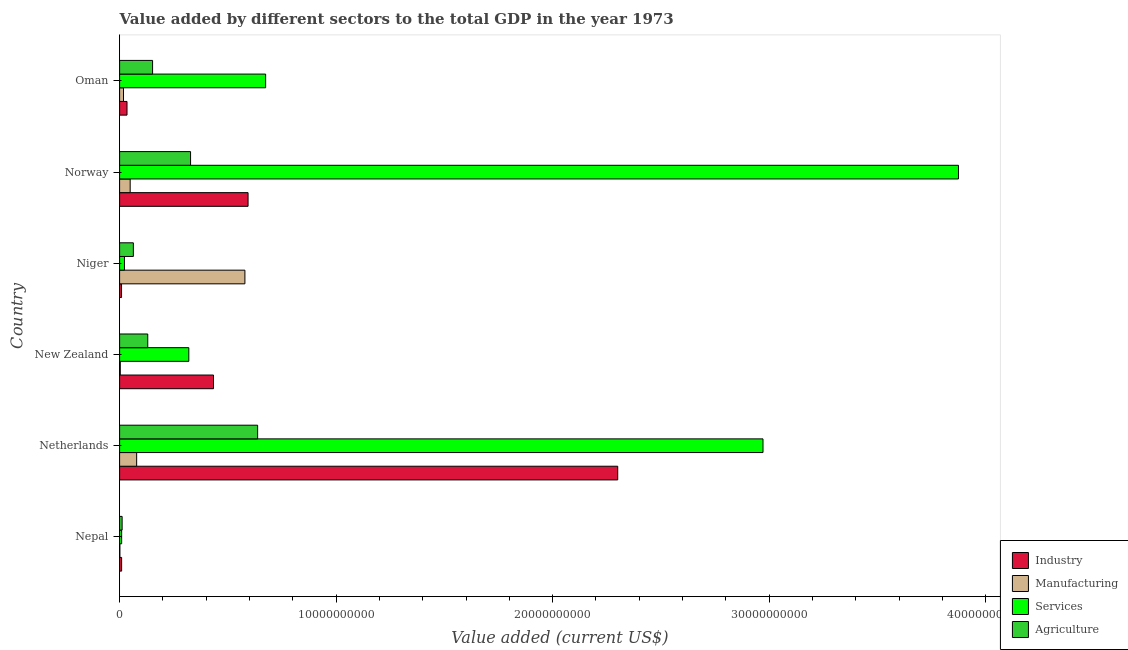How many different coloured bars are there?
Provide a succinct answer. 4. How many groups of bars are there?
Provide a succinct answer. 6. How many bars are there on the 6th tick from the top?
Offer a very short reply. 4. What is the label of the 4th group of bars from the top?
Offer a very short reply. New Zealand. In how many cases, is the number of bars for a given country not equal to the number of legend labels?
Provide a short and direct response. 0. What is the value added by industrial sector in Oman?
Your response must be concise. 3.42e+08. Across all countries, what is the maximum value added by agricultural sector?
Keep it short and to the point. 6.37e+09. Across all countries, what is the minimum value added by industrial sector?
Ensure brevity in your answer.  8.87e+07. In which country was the value added by agricultural sector minimum?
Keep it short and to the point. Nepal. What is the total value added by industrial sector in the graph?
Offer a very short reply. 3.38e+1. What is the difference between the value added by agricultural sector in Niger and that in Norway?
Your response must be concise. -2.64e+09. What is the difference between the value added by manufacturing sector in Norway and the value added by agricultural sector in Oman?
Your answer should be compact. -1.04e+09. What is the average value added by agricultural sector per country?
Provide a short and direct response. 2.20e+09. What is the difference between the value added by manufacturing sector and value added by agricultural sector in Niger?
Provide a succinct answer. 5.15e+09. What is the ratio of the value added by agricultural sector in Norway to that in Oman?
Give a very brief answer. 2.15. Is the value added by services sector in New Zealand less than that in Niger?
Your answer should be compact. No. What is the difference between the highest and the second highest value added by agricultural sector?
Your answer should be compact. 3.10e+09. What is the difference between the highest and the lowest value added by services sector?
Make the answer very short. 3.86e+1. In how many countries, is the value added by manufacturing sector greater than the average value added by manufacturing sector taken over all countries?
Ensure brevity in your answer.  1. What does the 1st bar from the top in Norway represents?
Provide a succinct answer. Agriculture. What does the 3rd bar from the bottom in Norway represents?
Offer a terse response. Services. Is it the case that in every country, the sum of the value added by industrial sector and value added by manufacturing sector is greater than the value added by services sector?
Your response must be concise. No. How many bars are there?
Your answer should be compact. 24. Are all the bars in the graph horizontal?
Offer a very short reply. Yes. Does the graph contain grids?
Provide a short and direct response. No. How are the legend labels stacked?
Provide a short and direct response. Vertical. What is the title of the graph?
Your answer should be compact. Value added by different sectors to the total GDP in the year 1973. Does "Minerals" appear as one of the legend labels in the graph?
Make the answer very short. No. What is the label or title of the X-axis?
Give a very brief answer. Value added (current US$). What is the Value added (current US$) in Industry in Nepal?
Offer a terse response. 9.32e+07. What is the Value added (current US$) of Manufacturing in Nepal?
Provide a short and direct response. 1.19e+07. What is the Value added (current US$) in Services in Nepal?
Provide a short and direct response. 9.44e+07. What is the Value added (current US$) of Agriculture in Nepal?
Provide a short and direct response. 1.17e+08. What is the Value added (current US$) of Industry in Netherlands?
Give a very brief answer. 2.30e+1. What is the Value added (current US$) in Manufacturing in Netherlands?
Give a very brief answer. 7.87e+08. What is the Value added (current US$) in Services in Netherlands?
Provide a short and direct response. 2.97e+1. What is the Value added (current US$) in Agriculture in Netherlands?
Your answer should be compact. 6.37e+09. What is the Value added (current US$) of Industry in New Zealand?
Give a very brief answer. 4.34e+09. What is the Value added (current US$) in Manufacturing in New Zealand?
Your answer should be very brief. 3.16e+07. What is the Value added (current US$) of Services in New Zealand?
Provide a short and direct response. 3.20e+09. What is the Value added (current US$) of Agriculture in New Zealand?
Ensure brevity in your answer.  1.30e+09. What is the Value added (current US$) in Industry in Niger?
Keep it short and to the point. 8.87e+07. What is the Value added (current US$) of Manufacturing in Niger?
Provide a succinct answer. 5.79e+09. What is the Value added (current US$) of Services in Niger?
Your answer should be very brief. 2.24e+08. What is the Value added (current US$) of Agriculture in Niger?
Keep it short and to the point. 6.35e+08. What is the Value added (current US$) in Industry in Norway?
Keep it short and to the point. 5.93e+09. What is the Value added (current US$) of Manufacturing in Norway?
Offer a terse response. 4.88e+08. What is the Value added (current US$) of Services in Norway?
Offer a terse response. 3.87e+1. What is the Value added (current US$) in Agriculture in Norway?
Give a very brief answer. 3.28e+09. What is the Value added (current US$) in Industry in Oman?
Your answer should be very brief. 3.42e+08. What is the Value added (current US$) in Manufacturing in Oman?
Provide a short and direct response. 1.80e+08. What is the Value added (current US$) in Services in Oman?
Offer a terse response. 6.74e+09. What is the Value added (current US$) of Agriculture in Oman?
Offer a terse response. 1.52e+09. Across all countries, what is the maximum Value added (current US$) in Industry?
Make the answer very short. 2.30e+1. Across all countries, what is the maximum Value added (current US$) in Manufacturing?
Give a very brief answer. 5.79e+09. Across all countries, what is the maximum Value added (current US$) of Services?
Your answer should be very brief. 3.87e+1. Across all countries, what is the maximum Value added (current US$) in Agriculture?
Your answer should be very brief. 6.37e+09. Across all countries, what is the minimum Value added (current US$) in Industry?
Ensure brevity in your answer.  8.87e+07. Across all countries, what is the minimum Value added (current US$) of Manufacturing?
Ensure brevity in your answer.  1.19e+07. Across all countries, what is the minimum Value added (current US$) in Services?
Your answer should be compact. 9.44e+07. Across all countries, what is the minimum Value added (current US$) of Agriculture?
Provide a short and direct response. 1.17e+08. What is the total Value added (current US$) of Industry in the graph?
Ensure brevity in your answer.  3.38e+1. What is the total Value added (current US$) in Manufacturing in the graph?
Ensure brevity in your answer.  7.29e+09. What is the total Value added (current US$) of Services in the graph?
Your answer should be very brief. 7.87e+1. What is the total Value added (current US$) in Agriculture in the graph?
Provide a succinct answer. 1.32e+1. What is the difference between the Value added (current US$) of Industry in Nepal and that in Netherlands?
Offer a very short reply. -2.29e+1. What is the difference between the Value added (current US$) in Manufacturing in Nepal and that in Netherlands?
Your response must be concise. -7.75e+08. What is the difference between the Value added (current US$) in Services in Nepal and that in Netherlands?
Make the answer very short. -2.96e+1. What is the difference between the Value added (current US$) in Agriculture in Nepal and that in Netherlands?
Provide a short and direct response. -6.26e+09. What is the difference between the Value added (current US$) of Industry in Nepal and that in New Zealand?
Give a very brief answer. -4.24e+09. What is the difference between the Value added (current US$) of Manufacturing in Nepal and that in New Zealand?
Your answer should be very brief. -1.97e+07. What is the difference between the Value added (current US$) in Services in Nepal and that in New Zealand?
Provide a short and direct response. -3.10e+09. What is the difference between the Value added (current US$) in Agriculture in Nepal and that in New Zealand?
Your answer should be compact. -1.18e+09. What is the difference between the Value added (current US$) of Industry in Nepal and that in Niger?
Provide a short and direct response. 4.47e+06. What is the difference between the Value added (current US$) of Manufacturing in Nepal and that in Niger?
Give a very brief answer. -5.78e+09. What is the difference between the Value added (current US$) of Services in Nepal and that in Niger?
Ensure brevity in your answer.  -1.29e+08. What is the difference between the Value added (current US$) of Agriculture in Nepal and that in Niger?
Provide a short and direct response. -5.18e+08. What is the difference between the Value added (current US$) of Industry in Nepal and that in Norway?
Offer a terse response. -5.84e+09. What is the difference between the Value added (current US$) of Manufacturing in Nepal and that in Norway?
Make the answer very short. -4.76e+08. What is the difference between the Value added (current US$) in Services in Nepal and that in Norway?
Offer a very short reply. -3.86e+1. What is the difference between the Value added (current US$) in Agriculture in Nepal and that in Norway?
Your answer should be very brief. -3.16e+09. What is the difference between the Value added (current US$) of Industry in Nepal and that in Oman?
Make the answer very short. -2.49e+08. What is the difference between the Value added (current US$) of Manufacturing in Nepal and that in Oman?
Give a very brief answer. -1.68e+08. What is the difference between the Value added (current US$) in Services in Nepal and that in Oman?
Offer a terse response. -6.65e+09. What is the difference between the Value added (current US$) in Agriculture in Nepal and that in Oman?
Provide a succinct answer. -1.41e+09. What is the difference between the Value added (current US$) in Industry in Netherlands and that in New Zealand?
Your answer should be compact. 1.87e+1. What is the difference between the Value added (current US$) in Manufacturing in Netherlands and that in New Zealand?
Offer a very short reply. 7.56e+08. What is the difference between the Value added (current US$) of Services in Netherlands and that in New Zealand?
Ensure brevity in your answer.  2.65e+1. What is the difference between the Value added (current US$) in Agriculture in Netherlands and that in New Zealand?
Your response must be concise. 5.07e+09. What is the difference between the Value added (current US$) in Industry in Netherlands and that in Niger?
Ensure brevity in your answer.  2.29e+1. What is the difference between the Value added (current US$) in Manufacturing in Netherlands and that in Niger?
Make the answer very short. -5.00e+09. What is the difference between the Value added (current US$) in Services in Netherlands and that in Niger?
Provide a succinct answer. 2.95e+1. What is the difference between the Value added (current US$) in Agriculture in Netherlands and that in Niger?
Provide a short and direct response. 5.74e+09. What is the difference between the Value added (current US$) of Industry in Netherlands and that in Norway?
Your response must be concise. 1.71e+1. What is the difference between the Value added (current US$) of Manufacturing in Netherlands and that in Norway?
Provide a succinct answer. 2.99e+08. What is the difference between the Value added (current US$) of Services in Netherlands and that in Norway?
Ensure brevity in your answer.  -9.03e+09. What is the difference between the Value added (current US$) of Agriculture in Netherlands and that in Norway?
Your answer should be compact. 3.10e+09. What is the difference between the Value added (current US$) in Industry in Netherlands and that in Oman?
Give a very brief answer. 2.27e+1. What is the difference between the Value added (current US$) in Manufacturing in Netherlands and that in Oman?
Your answer should be very brief. 6.07e+08. What is the difference between the Value added (current US$) of Services in Netherlands and that in Oman?
Your answer should be compact. 2.30e+1. What is the difference between the Value added (current US$) in Agriculture in Netherlands and that in Oman?
Ensure brevity in your answer.  4.85e+09. What is the difference between the Value added (current US$) of Industry in New Zealand and that in Niger?
Keep it short and to the point. 4.25e+09. What is the difference between the Value added (current US$) in Manufacturing in New Zealand and that in Niger?
Provide a succinct answer. -5.76e+09. What is the difference between the Value added (current US$) of Services in New Zealand and that in Niger?
Your answer should be very brief. 2.97e+09. What is the difference between the Value added (current US$) of Agriculture in New Zealand and that in Niger?
Keep it short and to the point. 6.65e+08. What is the difference between the Value added (current US$) of Industry in New Zealand and that in Norway?
Your answer should be very brief. -1.60e+09. What is the difference between the Value added (current US$) in Manufacturing in New Zealand and that in Norway?
Your answer should be very brief. -4.56e+08. What is the difference between the Value added (current US$) of Services in New Zealand and that in Norway?
Give a very brief answer. -3.55e+1. What is the difference between the Value added (current US$) in Agriculture in New Zealand and that in Norway?
Provide a short and direct response. -1.98e+09. What is the difference between the Value added (current US$) in Industry in New Zealand and that in Oman?
Your answer should be compact. 3.99e+09. What is the difference between the Value added (current US$) of Manufacturing in New Zealand and that in Oman?
Ensure brevity in your answer.  -1.48e+08. What is the difference between the Value added (current US$) of Services in New Zealand and that in Oman?
Your answer should be compact. -3.55e+09. What is the difference between the Value added (current US$) in Agriculture in New Zealand and that in Oman?
Provide a succinct answer. -2.23e+08. What is the difference between the Value added (current US$) in Industry in Niger and that in Norway?
Offer a very short reply. -5.84e+09. What is the difference between the Value added (current US$) of Manufacturing in Niger and that in Norway?
Provide a succinct answer. 5.30e+09. What is the difference between the Value added (current US$) of Services in Niger and that in Norway?
Offer a terse response. -3.85e+1. What is the difference between the Value added (current US$) in Agriculture in Niger and that in Norway?
Offer a very short reply. -2.64e+09. What is the difference between the Value added (current US$) of Industry in Niger and that in Oman?
Keep it short and to the point. -2.53e+08. What is the difference between the Value added (current US$) of Manufacturing in Niger and that in Oman?
Provide a short and direct response. 5.61e+09. What is the difference between the Value added (current US$) in Services in Niger and that in Oman?
Give a very brief answer. -6.52e+09. What is the difference between the Value added (current US$) in Agriculture in Niger and that in Oman?
Your response must be concise. -8.88e+08. What is the difference between the Value added (current US$) of Industry in Norway and that in Oman?
Ensure brevity in your answer.  5.59e+09. What is the difference between the Value added (current US$) of Manufacturing in Norway and that in Oman?
Ensure brevity in your answer.  3.08e+08. What is the difference between the Value added (current US$) of Services in Norway and that in Oman?
Provide a short and direct response. 3.20e+1. What is the difference between the Value added (current US$) of Agriculture in Norway and that in Oman?
Your answer should be compact. 1.75e+09. What is the difference between the Value added (current US$) in Industry in Nepal and the Value added (current US$) in Manufacturing in Netherlands?
Your answer should be very brief. -6.94e+08. What is the difference between the Value added (current US$) of Industry in Nepal and the Value added (current US$) of Services in Netherlands?
Provide a succinct answer. -2.96e+1. What is the difference between the Value added (current US$) in Industry in Nepal and the Value added (current US$) in Agriculture in Netherlands?
Provide a succinct answer. -6.28e+09. What is the difference between the Value added (current US$) of Manufacturing in Nepal and the Value added (current US$) of Services in Netherlands?
Your response must be concise. -2.97e+1. What is the difference between the Value added (current US$) in Manufacturing in Nepal and the Value added (current US$) in Agriculture in Netherlands?
Ensure brevity in your answer.  -6.36e+09. What is the difference between the Value added (current US$) in Services in Nepal and the Value added (current US$) in Agriculture in Netherlands?
Offer a very short reply. -6.28e+09. What is the difference between the Value added (current US$) of Industry in Nepal and the Value added (current US$) of Manufacturing in New Zealand?
Give a very brief answer. 6.16e+07. What is the difference between the Value added (current US$) in Industry in Nepal and the Value added (current US$) in Services in New Zealand?
Provide a short and direct response. -3.10e+09. What is the difference between the Value added (current US$) of Industry in Nepal and the Value added (current US$) of Agriculture in New Zealand?
Your answer should be compact. -1.21e+09. What is the difference between the Value added (current US$) in Manufacturing in Nepal and the Value added (current US$) in Services in New Zealand?
Give a very brief answer. -3.18e+09. What is the difference between the Value added (current US$) in Manufacturing in Nepal and the Value added (current US$) in Agriculture in New Zealand?
Make the answer very short. -1.29e+09. What is the difference between the Value added (current US$) of Services in Nepal and the Value added (current US$) of Agriculture in New Zealand?
Keep it short and to the point. -1.21e+09. What is the difference between the Value added (current US$) of Industry in Nepal and the Value added (current US$) of Manufacturing in Niger?
Ensure brevity in your answer.  -5.69e+09. What is the difference between the Value added (current US$) in Industry in Nepal and the Value added (current US$) in Services in Niger?
Offer a terse response. -1.31e+08. What is the difference between the Value added (current US$) of Industry in Nepal and the Value added (current US$) of Agriculture in Niger?
Ensure brevity in your answer.  -5.42e+08. What is the difference between the Value added (current US$) in Manufacturing in Nepal and the Value added (current US$) in Services in Niger?
Your response must be concise. -2.12e+08. What is the difference between the Value added (current US$) of Manufacturing in Nepal and the Value added (current US$) of Agriculture in Niger?
Make the answer very short. -6.23e+08. What is the difference between the Value added (current US$) of Services in Nepal and the Value added (current US$) of Agriculture in Niger?
Give a very brief answer. -5.41e+08. What is the difference between the Value added (current US$) in Industry in Nepal and the Value added (current US$) in Manufacturing in Norway?
Your response must be concise. -3.95e+08. What is the difference between the Value added (current US$) in Industry in Nepal and the Value added (current US$) in Services in Norway?
Ensure brevity in your answer.  -3.86e+1. What is the difference between the Value added (current US$) of Industry in Nepal and the Value added (current US$) of Agriculture in Norway?
Your response must be concise. -3.18e+09. What is the difference between the Value added (current US$) in Manufacturing in Nepal and the Value added (current US$) in Services in Norway?
Give a very brief answer. -3.87e+1. What is the difference between the Value added (current US$) of Manufacturing in Nepal and the Value added (current US$) of Agriculture in Norway?
Your answer should be very brief. -3.27e+09. What is the difference between the Value added (current US$) of Services in Nepal and the Value added (current US$) of Agriculture in Norway?
Keep it short and to the point. -3.18e+09. What is the difference between the Value added (current US$) of Industry in Nepal and the Value added (current US$) of Manufacturing in Oman?
Make the answer very short. -8.66e+07. What is the difference between the Value added (current US$) in Industry in Nepal and the Value added (current US$) in Services in Oman?
Your answer should be very brief. -6.65e+09. What is the difference between the Value added (current US$) of Industry in Nepal and the Value added (current US$) of Agriculture in Oman?
Your answer should be very brief. -1.43e+09. What is the difference between the Value added (current US$) of Manufacturing in Nepal and the Value added (current US$) of Services in Oman?
Ensure brevity in your answer.  -6.73e+09. What is the difference between the Value added (current US$) of Manufacturing in Nepal and the Value added (current US$) of Agriculture in Oman?
Keep it short and to the point. -1.51e+09. What is the difference between the Value added (current US$) in Services in Nepal and the Value added (current US$) in Agriculture in Oman?
Provide a short and direct response. -1.43e+09. What is the difference between the Value added (current US$) in Industry in Netherlands and the Value added (current US$) in Manufacturing in New Zealand?
Your answer should be very brief. 2.30e+1. What is the difference between the Value added (current US$) in Industry in Netherlands and the Value added (current US$) in Services in New Zealand?
Your response must be concise. 1.98e+1. What is the difference between the Value added (current US$) in Industry in Netherlands and the Value added (current US$) in Agriculture in New Zealand?
Ensure brevity in your answer.  2.17e+1. What is the difference between the Value added (current US$) in Manufacturing in Netherlands and the Value added (current US$) in Services in New Zealand?
Keep it short and to the point. -2.41e+09. What is the difference between the Value added (current US$) of Manufacturing in Netherlands and the Value added (current US$) of Agriculture in New Zealand?
Your answer should be very brief. -5.13e+08. What is the difference between the Value added (current US$) of Services in Netherlands and the Value added (current US$) of Agriculture in New Zealand?
Provide a succinct answer. 2.84e+1. What is the difference between the Value added (current US$) in Industry in Netherlands and the Value added (current US$) in Manufacturing in Niger?
Your answer should be very brief. 1.72e+1. What is the difference between the Value added (current US$) in Industry in Netherlands and the Value added (current US$) in Services in Niger?
Give a very brief answer. 2.28e+1. What is the difference between the Value added (current US$) of Industry in Netherlands and the Value added (current US$) of Agriculture in Niger?
Ensure brevity in your answer.  2.24e+1. What is the difference between the Value added (current US$) of Manufacturing in Netherlands and the Value added (current US$) of Services in Niger?
Your answer should be very brief. 5.63e+08. What is the difference between the Value added (current US$) of Manufacturing in Netherlands and the Value added (current US$) of Agriculture in Niger?
Give a very brief answer. 1.52e+08. What is the difference between the Value added (current US$) in Services in Netherlands and the Value added (current US$) in Agriculture in Niger?
Your response must be concise. 2.91e+1. What is the difference between the Value added (current US$) of Industry in Netherlands and the Value added (current US$) of Manufacturing in Norway?
Make the answer very short. 2.25e+1. What is the difference between the Value added (current US$) of Industry in Netherlands and the Value added (current US$) of Services in Norway?
Offer a very short reply. -1.57e+1. What is the difference between the Value added (current US$) in Industry in Netherlands and the Value added (current US$) in Agriculture in Norway?
Ensure brevity in your answer.  1.97e+1. What is the difference between the Value added (current US$) of Manufacturing in Netherlands and the Value added (current US$) of Services in Norway?
Give a very brief answer. -3.80e+1. What is the difference between the Value added (current US$) in Manufacturing in Netherlands and the Value added (current US$) in Agriculture in Norway?
Provide a short and direct response. -2.49e+09. What is the difference between the Value added (current US$) of Services in Netherlands and the Value added (current US$) of Agriculture in Norway?
Keep it short and to the point. 2.64e+1. What is the difference between the Value added (current US$) of Industry in Netherlands and the Value added (current US$) of Manufacturing in Oman?
Offer a terse response. 2.28e+1. What is the difference between the Value added (current US$) in Industry in Netherlands and the Value added (current US$) in Services in Oman?
Ensure brevity in your answer.  1.63e+1. What is the difference between the Value added (current US$) in Industry in Netherlands and the Value added (current US$) in Agriculture in Oman?
Offer a very short reply. 2.15e+1. What is the difference between the Value added (current US$) of Manufacturing in Netherlands and the Value added (current US$) of Services in Oman?
Provide a succinct answer. -5.96e+09. What is the difference between the Value added (current US$) in Manufacturing in Netherlands and the Value added (current US$) in Agriculture in Oman?
Make the answer very short. -7.36e+08. What is the difference between the Value added (current US$) in Services in Netherlands and the Value added (current US$) in Agriculture in Oman?
Provide a short and direct response. 2.82e+1. What is the difference between the Value added (current US$) of Industry in New Zealand and the Value added (current US$) of Manufacturing in Niger?
Your response must be concise. -1.45e+09. What is the difference between the Value added (current US$) in Industry in New Zealand and the Value added (current US$) in Services in Niger?
Keep it short and to the point. 4.11e+09. What is the difference between the Value added (current US$) in Industry in New Zealand and the Value added (current US$) in Agriculture in Niger?
Your answer should be compact. 3.70e+09. What is the difference between the Value added (current US$) in Manufacturing in New Zealand and the Value added (current US$) in Services in Niger?
Your answer should be very brief. -1.92e+08. What is the difference between the Value added (current US$) in Manufacturing in New Zealand and the Value added (current US$) in Agriculture in Niger?
Offer a very short reply. -6.03e+08. What is the difference between the Value added (current US$) in Services in New Zealand and the Value added (current US$) in Agriculture in Niger?
Make the answer very short. 2.56e+09. What is the difference between the Value added (current US$) of Industry in New Zealand and the Value added (current US$) of Manufacturing in Norway?
Give a very brief answer. 3.85e+09. What is the difference between the Value added (current US$) in Industry in New Zealand and the Value added (current US$) in Services in Norway?
Your response must be concise. -3.44e+1. What is the difference between the Value added (current US$) in Industry in New Zealand and the Value added (current US$) in Agriculture in Norway?
Offer a terse response. 1.06e+09. What is the difference between the Value added (current US$) of Manufacturing in New Zealand and the Value added (current US$) of Services in Norway?
Make the answer very short. -3.87e+1. What is the difference between the Value added (current US$) of Manufacturing in New Zealand and the Value added (current US$) of Agriculture in Norway?
Ensure brevity in your answer.  -3.25e+09. What is the difference between the Value added (current US$) in Services in New Zealand and the Value added (current US$) in Agriculture in Norway?
Provide a short and direct response. -8.06e+07. What is the difference between the Value added (current US$) of Industry in New Zealand and the Value added (current US$) of Manufacturing in Oman?
Your answer should be compact. 4.16e+09. What is the difference between the Value added (current US$) in Industry in New Zealand and the Value added (current US$) in Services in Oman?
Provide a succinct answer. -2.41e+09. What is the difference between the Value added (current US$) in Industry in New Zealand and the Value added (current US$) in Agriculture in Oman?
Your answer should be very brief. 2.81e+09. What is the difference between the Value added (current US$) of Manufacturing in New Zealand and the Value added (current US$) of Services in Oman?
Make the answer very short. -6.71e+09. What is the difference between the Value added (current US$) of Manufacturing in New Zealand and the Value added (current US$) of Agriculture in Oman?
Provide a short and direct response. -1.49e+09. What is the difference between the Value added (current US$) in Services in New Zealand and the Value added (current US$) in Agriculture in Oman?
Your answer should be compact. 1.67e+09. What is the difference between the Value added (current US$) of Industry in Niger and the Value added (current US$) of Manufacturing in Norway?
Ensure brevity in your answer.  -3.99e+08. What is the difference between the Value added (current US$) of Industry in Niger and the Value added (current US$) of Services in Norway?
Offer a very short reply. -3.87e+1. What is the difference between the Value added (current US$) of Industry in Niger and the Value added (current US$) of Agriculture in Norway?
Provide a succinct answer. -3.19e+09. What is the difference between the Value added (current US$) of Manufacturing in Niger and the Value added (current US$) of Services in Norway?
Your answer should be compact. -3.30e+1. What is the difference between the Value added (current US$) in Manufacturing in Niger and the Value added (current US$) in Agriculture in Norway?
Your answer should be compact. 2.51e+09. What is the difference between the Value added (current US$) of Services in Niger and the Value added (current US$) of Agriculture in Norway?
Ensure brevity in your answer.  -3.05e+09. What is the difference between the Value added (current US$) in Industry in Niger and the Value added (current US$) in Manufacturing in Oman?
Your response must be concise. -9.10e+07. What is the difference between the Value added (current US$) of Industry in Niger and the Value added (current US$) of Services in Oman?
Provide a short and direct response. -6.66e+09. What is the difference between the Value added (current US$) in Industry in Niger and the Value added (current US$) in Agriculture in Oman?
Offer a very short reply. -1.43e+09. What is the difference between the Value added (current US$) in Manufacturing in Niger and the Value added (current US$) in Services in Oman?
Offer a terse response. -9.57e+08. What is the difference between the Value added (current US$) in Manufacturing in Niger and the Value added (current US$) in Agriculture in Oman?
Offer a terse response. 4.26e+09. What is the difference between the Value added (current US$) in Services in Niger and the Value added (current US$) in Agriculture in Oman?
Offer a terse response. -1.30e+09. What is the difference between the Value added (current US$) in Industry in Norway and the Value added (current US$) in Manufacturing in Oman?
Your response must be concise. 5.75e+09. What is the difference between the Value added (current US$) of Industry in Norway and the Value added (current US$) of Services in Oman?
Provide a short and direct response. -8.12e+08. What is the difference between the Value added (current US$) of Industry in Norway and the Value added (current US$) of Agriculture in Oman?
Your response must be concise. 4.41e+09. What is the difference between the Value added (current US$) in Manufacturing in Norway and the Value added (current US$) in Services in Oman?
Make the answer very short. -6.26e+09. What is the difference between the Value added (current US$) of Manufacturing in Norway and the Value added (current US$) of Agriculture in Oman?
Give a very brief answer. -1.04e+09. What is the difference between the Value added (current US$) of Services in Norway and the Value added (current US$) of Agriculture in Oman?
Your answer should be compact. 3.72e+1. What is the average Value added (current US$) of Industry per country?
Provide a succinct answer. 5.63e+09. What is the average Value added (current US$) of Manufacturing per country?
Keep it short and to the point. 1.21e+09. What is the average Value added (current US$) of Services per country?
Keep it short and to the point. 1.31e+1. What is the average Value added (current US$) in Agriculture per country?
Provide a succinct answer. 2.20e+09. What is the difference between the Value added (current US$) in Industry and Value added (current US$) in Manufacturing in Nepal?
Ensure brevity in your answer.  8.13e+07. What is the difference between the Value added (current US$) of Industry and Value added (current US$) of Services in Nepal?
Keep it short and to the point. -1.17e+06. What is the difference between the Value added (current US$) of Industry and Value added (current US$) of Agriculture in Nepal?
Your answer should be compact. -2.35e+07. What is the difference between the Value added (current US$) in Manufacturing and Value added (current US$) in Services in Nepal?
Give a very brief answer. -8.25e+07. What is the difference between the Value added (current US$) of Manufacturing and Value added (current US$) of Agriculture in Nepal?
Provide a succinct answer. -1.05e+08. What is the difference between the Value added (current US$) in Services and Value added (current US$) in Agriculture in Nepal?
Your answer should be very brief. -2.23e+07. What is the difference between the Value added (current US$) in Industry and Value added (current US$) in Manufacturing in Netherlands?
Ensure brevity in your answer.  2.22e+1. What is the difference between the Value added (current US$) of Industry and Value added (current US$) of Services in Netherlands?
Offer a terse response. -6.71e+09. What is the difference between the Value added (current US$) in Industry and Value added (current US$) in Agriculture in Netherlands?
Ensure brevity in your answer.  1.66e+1. What is the difference between the Value added (current US$) in Manufacturing and Value added (current US$) in Services in Netherlands?
Your response must be concise. -2.89e+1. What is the difference between the Value added (current US$) of Manufacturing and Value added (current US$) of Agriculture in Netherlands?
Ensure brevity in your answer.  -5.59e+09. What is the difference between the Value added (current US$) of Services and Value added (current US$) of Agriculture in Netherlands?
Give a very brief answer. 2.33e+1. What is the difference between the Value added (current US$) in Industry and Value added (current US$) in Manufacturing in New Zealand?
Make the answer very short. 4.31e+09. What is the difference between the Value added (current US$) of Industry and Value added (current US$) of Services in New Zealand?
Offer a very short reply. 1.14e+09. What is the difference between the Value added (current US$) of Industry and Value added (current US$) of Agriculture in New Zealand?
Give a very brief answer. 3.04e+09. What is the difference between the Value added (current US$) in Manufacturing and Value added (current US$) in Services in New Zealand?
Keep it short and to the point. -3.16e+09. What is the difference between the Value added (current US$) of Manufacturing and Value added (current US$) of Agriculture in New Zealand?
Keep it short and to the point. -1.27e+09. What is the difference between the Value added (current US$) in Services and Value added (current US$) in Agriculture in New Zealand?
Provide a short and direct response. 1.90e+09. What is the difference between the Value added (current US$) in Industry and Value added (current US$) in Manufacturing in Niger?
Your response must be concise. -5.70e+09. What is the difference between the Value added (current US$) in Industry and Value added (current US$) in Services in Niger?
Provide a succinct answer. -1.35e+08. What is the difference between the Value added (current US$) of Industry and Value added (current US$) of Agriculture in Niger?
Your answer should be compact. -5.46e+08. What is the difference between the Value added (current US$) in Manufacturing and Value added (current US$) in Services in Niger?
Your answer should be compact. 5.56e+09. What is the difference between the Value added (current US$) in Manufacturing and Value added (current US$) in Agriculture in Niger?
Provide a succinct answer. 5.15e+09. What is the difference between the Value added (current US$) of Services and Value added (current US$) of Agriculture in Niger?
Keep it short and to the point. -4.11e+08. What is the difference between the Value added (current US$) in Industry and Value added (current US$) in Manufacturing in Norway?
Offer a terse response. 5.44e+09. What is the difference between the Value added (current US$) in Industry and Value added (current US$) in Services in Norway?
Make the answer very short. -3.28e+1. What is the difference between the Value added (current US$) of Industry and Value added (current US$) of Agriculture in Norway?
Your answer should be very brief. 2.66e+09. What is the difference between the Value added (current US$) of Manufacturing and Value added (current US$) of Services in Norway?
Provide a short and direct response. -3.83e+1. What is the difference between the Value added (current US$) in Manufacturing and Value added (current US$) in Agriculture in Norway?
Make the answer very short. -2.79e+09. What is the difference between the Value added (current US$) in Services and Value added (current US$) in Agriculture in Norway?
Your response must be concise. 3.55e+1. What is the difference between the Value added (current US$) in Industry and Value added (current US$) in Manufacturing in Oman?
Your response must be concise. 1.62e+08. What is the difference between the Value added (current US$) in Industry and Value added (current US$) in Services in Oman?
Ensure brevity in your answer.  -6.40e+09. What is the difference between the Value added (current US$) in Industry and Value added (current US$) in Agriculture in Oman?
Your response must be concise. -1.18e+09. What is the difference between the Value added (current US$) of Manufacturing and Value added (current US$) of Services in Oman?
Provide a succinct answer. -6.56e+09. What is the difference between the Value added (current US$) in Manufacturing and Value added (current US$) in Agriculture in Oman?
Provide a short and direct response. -1.34e+09. What is the difference between the Value added (current US$) of Services and Value added (current US$) of Agriculture in Oman?
Offer a terse response. 5.22e+09. What is the ratio of the Value added (current US$) of Industry in Nepal to that in Netherlands?
Ensure brevity in your answer.  0. What is the ratio of the Value added (current US$) of Manufacturing in Nepal to that in Netherlands?
Provide a short and direct response. 0.02. What is the ratio of the Value added (current US$) of Services in Nepal to that in Netherlands?
Offer a terse response. 0. What is the ratio of the Value added (current US$) in Agriculture in Nepal to that in Netherlands?
Keep it short and to the point. 0.02. What is the ratio of the Value added (current US$) in Industry in Nepal to that in New Zealand?
Provide a short and direct response. 0.02. What is the ratio of the Value added (current US$) in Manufacturing in Nepal to that in New Zealand?
Your answer should be compact. 0.38. What is the ratio of the Value added (current US$) of Services in Nepal to that in New Zealand?
Provide a short and direct response. 0.03. What is the ratio of the Value added (current US$) in Agriculture in Nepal to that in New Zealand?
Make the answer very short. 0.09. What is the ratio of the Value added (current US$) of Industry in Nepal to that in Niger?
Make the answer very short. 1.05. What is the ratio of the Value added (current US$) of Manufacturing in Nepal to that in Niger?
Provide a short and direct response. 0. What is the ratio of the Value added (current US$) in Services in Nepal to that in Niger?
Provide a succinct answer. 0.42. What is the ratio of the Value added (current US$) in Agriculture in Nepal to that in Niger?
Offer a terse response. 0.18. What is the ratio of the Value added (current US$) in Industry in Nepal to that in Norway?
Ensure brevity in your answer.  0.02. What is the ratio of the Value added (current US$) of Manufacturing in Nepal to that in Norway?
Ensure brevity in your answer.  0.02. What is the ratio of the Value added (current US$) of Services in Nepal to that in Norway?
Give a very brief answer. 0. What is the ratio of the Value added (current US$) of Agriculture in Nepal to that in Norway?
Offer a very short reply. 0.04. What is the ratio of the Value added (current US$) in Industry in Nepal to that in Oman?
Offer a terse response. 0.27. What is the ratio of the Value added (current US$) in Manufacturing in Nepal to that in Oman?
Your response must be concise. 0.07. What is the ratio of the Value added (current US$) of Services in Nepal to that in Oman?
Provide a succinct answer. 0.01. What is the ratio of the Value added (current US$) in Agriculture in Nepal to that in Oman?
Offer a very short reply. 0.08. What is the ratio of the Value added (current US$) in Industry in Netherlands to that in New Zealand?
Provide a succinct answer. 5.3. What is the ratio of the Value added (current US$) in Manufacturing in Netherlands to that in New Zealand?
Offer a very short reply. 24.91. What is the ratio of the Value added (current US$) in Services in Netherlands to that in New Zealand?
Offer a very short reply. 9.3. What is the ratio of the Value added (current US$) in Agriculture in Netherlands to that in New Zealand?
Make the answer very short. 4.9. What is the ratio of the Value added (current US$) in Industry in Netherlands to that in Niger?
Provide a succinct answer. 259.2. What is the ratio of the Value added (current US$) of Manufacturing in Netherlands to that in Niger?
Make the answer very short. 0.14. What is the ratio of the Value added (current US$) in Services in Netherlands to that in Niger?
Your answer should be very brief. 132.72. What is the ratio of the Value added (current US$) of Agriculture in Netherlands to that in Niger?
Your response must be concise. 10.04. What is the ratio of the Value added (current US$) of Industry in Netherlands to that in Norway?
Provide a succinct answer. 3.88. What is the ratio of the Value added (current US$) in Manufacturing in Netherlands to that in Norway?
Keep it short and to the point. 1.61. What is the ratio of the Value added (current US$) of Services in Netherlands to that in Norway?
Your answer should be compact. 0.77. What is the ratio of the Value added (current US$) in Agriculture in Netherlands to that in Norway?
Ensure brevity in your answer.  1.95. What is the ratio of the Value added (current US$) in Industry in Netherlands to that in Oman?
Make the answer very short. 67.23. What is the ratio of the Value added (current US$) in Manufacturing in Netherlands to that in Oman?
Give a very brief answer. 4.38. What is the ratio of the Value added (current US$) of Services in Netherlands to that in Oman?
Your answer should be compact. 4.41. What is the ratio of the Value added (current US$) in Agriculture in Netherlands to that in Oman?
Your response must be concise. 4.19. What is the ratio of the Value added (current US$) of Industry in New Zealand to that in Niger?
Give a very brief answer. 48.86. What is the ratio of the Value added (current US$) of Manufacturing in New Zealand to that in Niger?
Give a very brief answer. 0.01. What is the ratio of the Value added (current US$) in Services in New Zealand to that in Niger?
Your answer should be very brief. 14.28. What is the ratio of the Value added (current US$) of Agriculture in New Zealand to that in Niger?
Ensure brevity in your answer.  2.05. What is the ratio of the Value added (current US$) of Industry in New Zealand to that in Norway?
Offer a terse response. 0.73. What is the ratio of the Value added (current US$) of Manufacturing in New Zealand to that in Norway?
Keep it short and to the point. 0.06. What is the ratio of the Value added (current US$) of Services in New Zealand to that in Norway?
Provide a succinct answer. 0.08. What is the ratio of the Value added (current US$) of Agriculture in New Zealand to that in Norway?
Ensure brevity in your answer.  0.4. What is the ratio of the Value added (current US$) of Industry in New Zealand to that in Oman?
Your answer should be compact. 12.67. What is the ratio of the Value added (current US$) of Manufacturing in New Zealand to that in Oman?
Keep it short and to the point. 0.18. What is the ratio of the Value added (current US$) in Services in New Zealand to that in Oman?
Make the answer very short. 0.47. What is the ratio of the Value added (current US$) in Agriculture in New Zealand to that in Oman?
Keep it short and to the point. 0.85. What is the ratio of the Value added (current US$) of Industry in Niger to that in Norway?
Provide a short and direct response. 0.01. What is the ratio of the Value added (current US$) of Manufacturing in Niger to that in Norway?
Provide a short and direct response. 11.86. What is the ratio of the Value added (current US$) of Services in Niger to that in Norway?
Provide a succinct answer. 0.01. What is the ratio of the Value added (current US$) of Agriculture in Niger to that in Norway?
Your answer should be very brief. 0.19. What is the ratio of the Value added (current US$) in Industry in Niger to that in Oman?
Make the answer very short. 0.26. What is the ratio of the Value added (current US$) of Manufacturing in Niger to that in Oman?
Give a very brief answer. 32.19. What is the ratio of the Value added (current US$) in Services in Niger to that in Oman?
Give a very brief answer. 0.03. What is the ratio of the Value added (current US$) in Agriculture in Niger to that in Oman?
Ensure brevity in your answer.  0.42. What is the ratio of the Value added (current US$) of Industry in Norway to that in Oman?
Offer a terse response. 17.34. What is the ratio of the Value added (current US$) of Manufacturing in Norway to that in Oman?
Your answer should be very brief. 2.71. What is the ratio of the Value added (current US$) of Services in Norway to that in Oman?
Your answer should be compact. 5.74. What is the ratio of the Value added (current US$) of Agriculture in Norway to that in Oman?
Make the answer very short. 2.15. What is the difference between the highest and the second highest Value added (current US$) of Industry?
Keep it short and to the point. 1.71e+1. What is the difference between the highest and the second highest Value added (current US$) of Manufacturing?
Make the answer very short. 5.00e+09. What is the difference between the highest and the second highest Value added (current US$) in Services?
Offer a very short reply. 9.03e+09. What is the difference between the highest and the second highest Value added (current US$) in Agriculture?
Provide a succinct answer. 3.10e+09. What is the difference between the highest and the lowest Value added (current US$) in Industry?
Make the answer very short. 2.29e+1. What is the difference between the highest and the lowest Value added (current US$) of Manufacturing?
Offer a terse response. 5.78e+09. What is the difference between the highest and the lowest Value added (current US$) in Services?
Give a very brief answer. 3.86e+1. What is the difference between the highest and the lowest Value added (current US$) in Agriculture?
Give a very brief answer. 6.26e+09. 